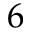Convert formula to latex. <formula><loc_0><loc_0><loc_500><loc_500>6</formula> 